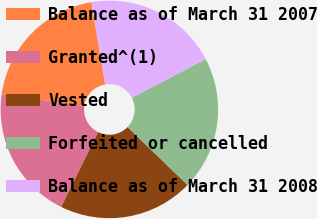Convert chart. <chart><loc_0><loc_0><loc_500><loc_500><pie_chart><fcel>Balance as of March 31 2007<fcel>Granted^(1)<fcel>Vested<fcel>Forfeited or cancelled<fcel>Balance as of March 31 2008<nl><fcel>20.13%<fcel>19.92%<fcel>20.07%<fcel>19.89%<fcel>19.98%<nl></chart> 